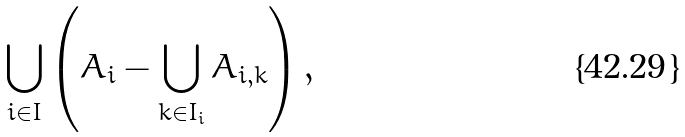Convert formula to latex. <formula><loc_0><loc_0><loc_500><loc_500>\bigcup _ { i \in I } \left ( A _ { i } - \bigcup _ { k \in I _ { i } } A _ { i , k } \right ) ,</formula> 